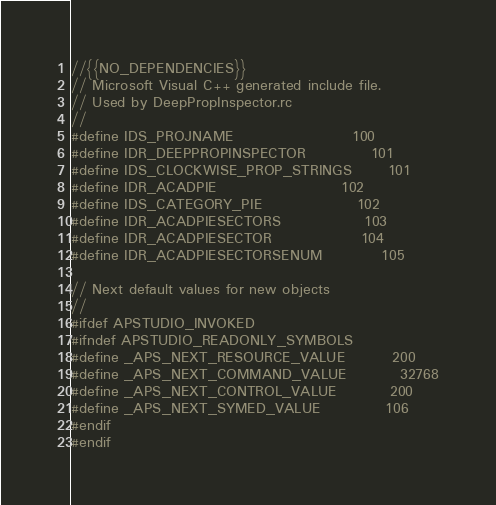<code> <loc_0><loc_0><loc_500><loc_500><_C_>//{{NO_DEPENDENCIES}}
// Microsoft Visual C++ generated include file.
// Used by DeepPropInspector.rc
//
#define IDS_PROJNAME                    100
#define IDR_DEEPPROPINSPECTOR           101
#define IDS_CLOCKWISE_PROP_STRINGS      101
#define IDR_ACADPIE                     102
#define IDS_CATEGORY_PIE                102
#define IDR_ACADPIESECTORS              103
#define IDR_ACADPIESECTOR               104
#define IDR_ACADPIESECTORSENUM          105

// Next default values for new objects
// 
#ifdef APSTUDIO_INVOKED
#ifndef APSTUDIO_READONLY_SYMBOLS
#define _APS_NEXT_RESOURCE_VALUE        200
#define _APS_NEXT_COMMAND_VALUE         32768
#define _APS_NEXT_CONTROL_VALUE         200
#define _APS_NEXT_SYMED_VALUE           106
#endif
#endif
</code> 